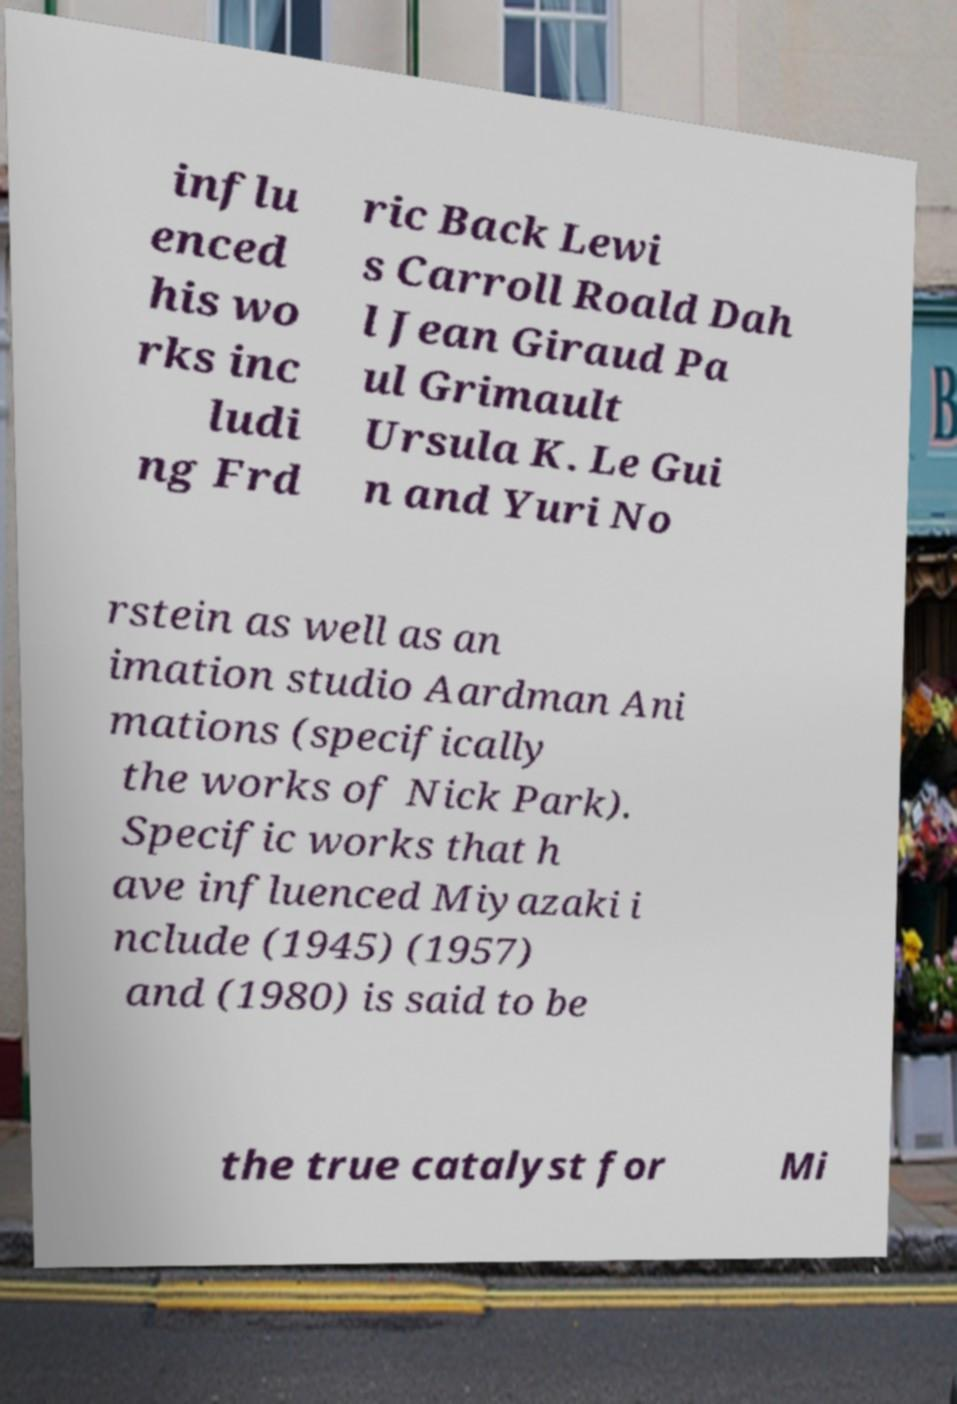Please read and relay the text visible in this image. What does it say? influ enced his wo rks inc ludi ng Frd ric Back Lewi s Carroll Roald Dah l Jean Giraud Pa ul Grimault Ursula K. Le Gui n and Yuri No rstein as well as an imation studio Aardman Ani mations (specifically the works of Nick Park). Specific works that h ave influenced Miyazaki i nclude (1945) (1957) and (1980) is said to be the true catalyst for Mi 